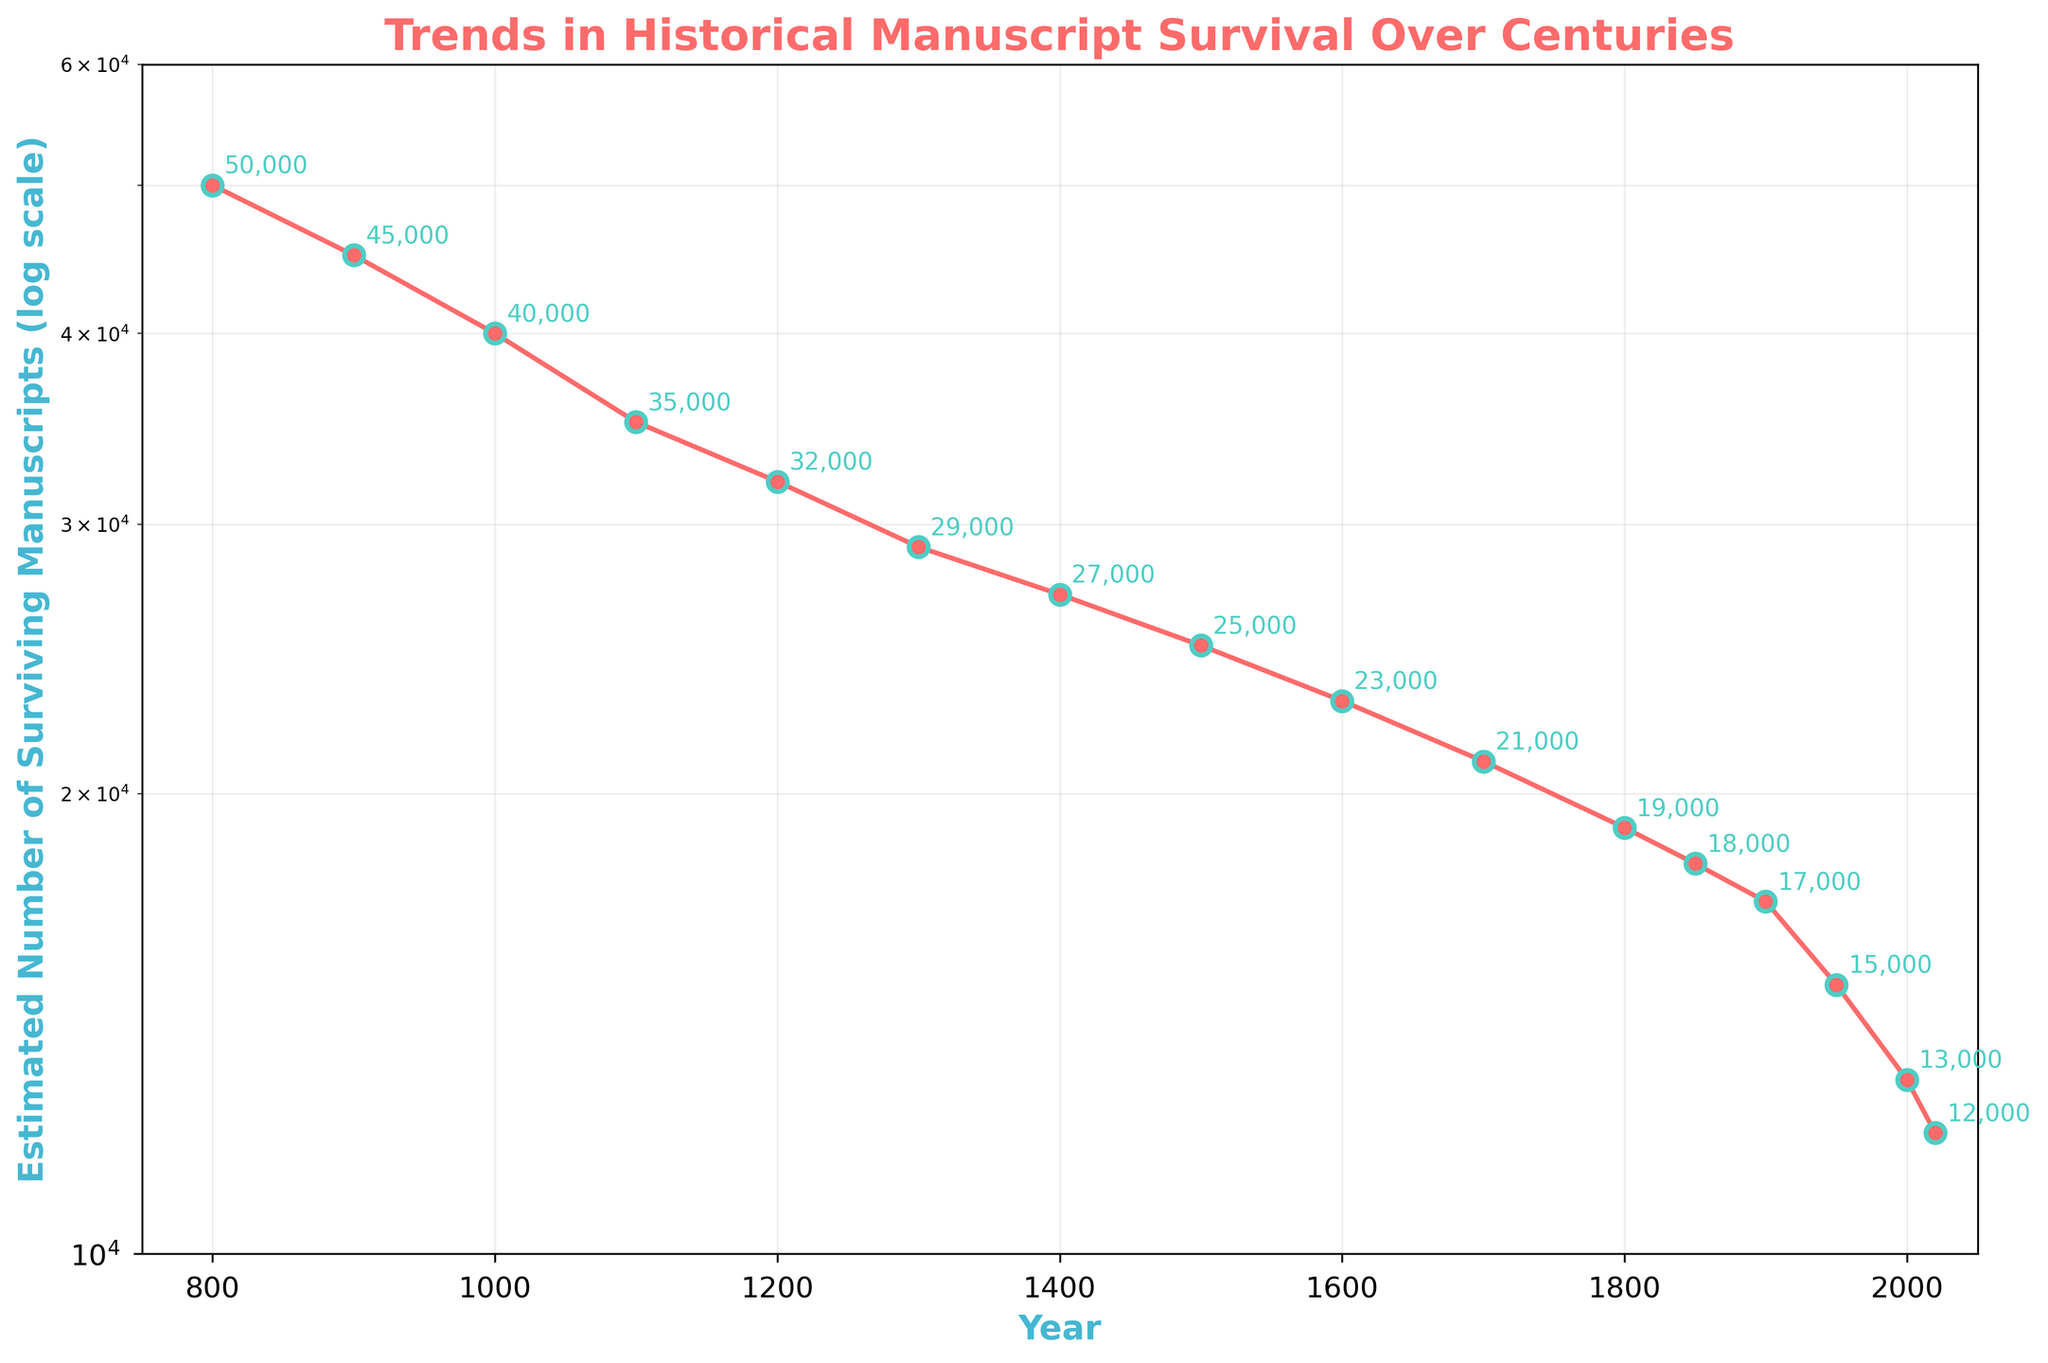What's the title of the figure? The title of the figure is displayed prominently at the top and clearly states the subject of the plot.
Answer: Trends in Historical Manuscript Survival Over Centuries What does the y-axis represent? The label on the y-axis indicates what is being measured; here, it represents the estimated number of surviving manuscripts on a logarithmic scale.
Answer: Estimated Number of Surviving Manuscripts (log scale) How many years are displayed on the x-axis? Counting the data points along the x-axis from the start year to the end year shows the timeline represented in the plot.
Answer: 16 What is the general trend in the number of surviving manuscripts over time? Observing the curve formed by the data points, there is a steady decline in the number of surviving manuscripts from the earliest years to the latest.
Answer: A steady decline Between which two consecutive centuries does the smallest decline in the number of manuscripts appear? By examining the plot and comparing the distances between consecutive points, we can determine that the smallest decline occurs between the year with the closest values.
Answer: 1850 to 1900 In which century did the estimated number of surviving manuscripts fall below 20,000 for the first time? By looking at the y-values corresponding to the x-values (years), the number falls below 20,000 between two specific points, 1800 and 1850, so the century is the 19th.
Answer: 19th century What is the approximate percentage decrease in the number of manuscripts from the year 800 to the year 2020? First, calculate the initial and final values of manuscripts. The percentage decrease is given by the formula: ((initial - final) / initial) * 100. For 800 to 2020, it is ((50000 - 12000) / 50000) * 100.
Answer: 76% Which year marks the largest drop in the number of manuscripts surviving within a century? By checking the points and seeing the largest vertical gap on a logarithmic scale, we identify the most substantial drop occurs between 2000 and 2020, indicating recent years have the largest drop.
Answer: 2000 What color are the plot points and lines representing the data on the figure? The plot uses specific colors for visibility, with points marked in a distinctive color and lines connecting them.
Answer: Points: Red, Lines: Red 